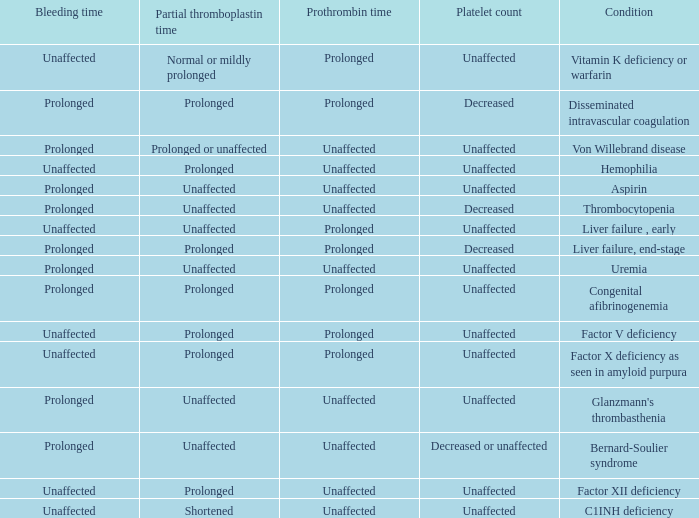Which Platelet count has a Condition of factor v deficiency? Unaffected. 